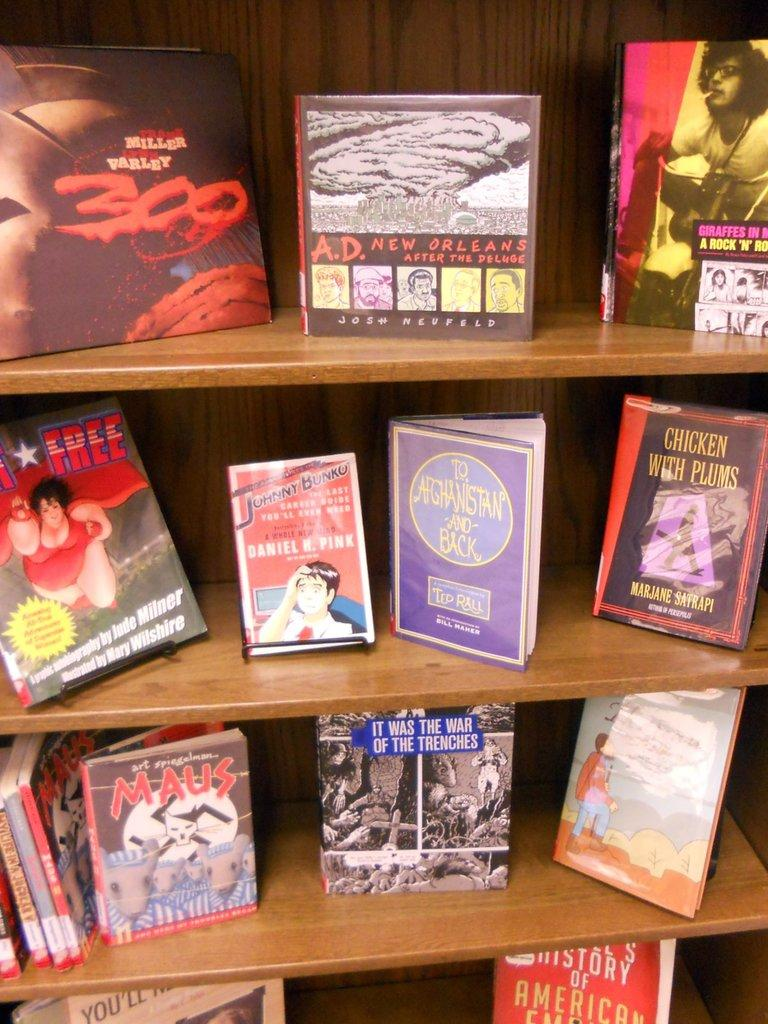<image>
Relay a brief, clear account of the picture shown. several books including 300 by Frank Miller and Lynn Varley sit on display 